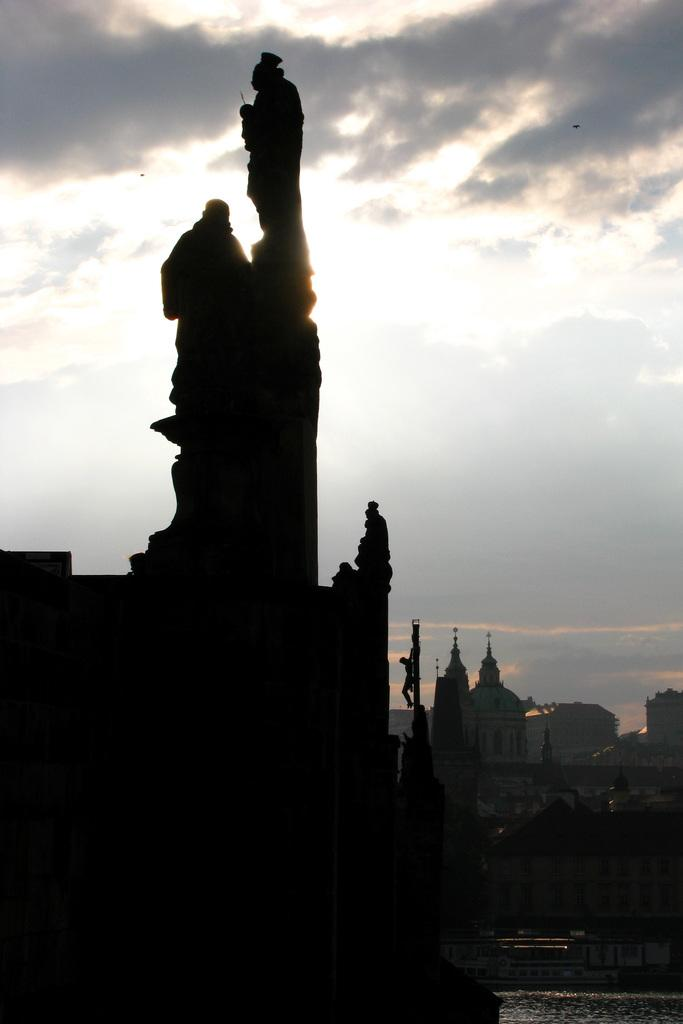What is located on the left side of the image? There is a statue on the left side of the image. What is near the statue? There is a lake beside the statue. What can be seen in the background of the image? There are buildings in the background of the image. What is visible at the top of the image? The sky is visible in the image. What can be observed in the sky? Clouds are present in the sky. What type of wall can be seen in the image? There is no wall present in the image. What kind of competition is taking place near the statue? There is no competition present in the image. 